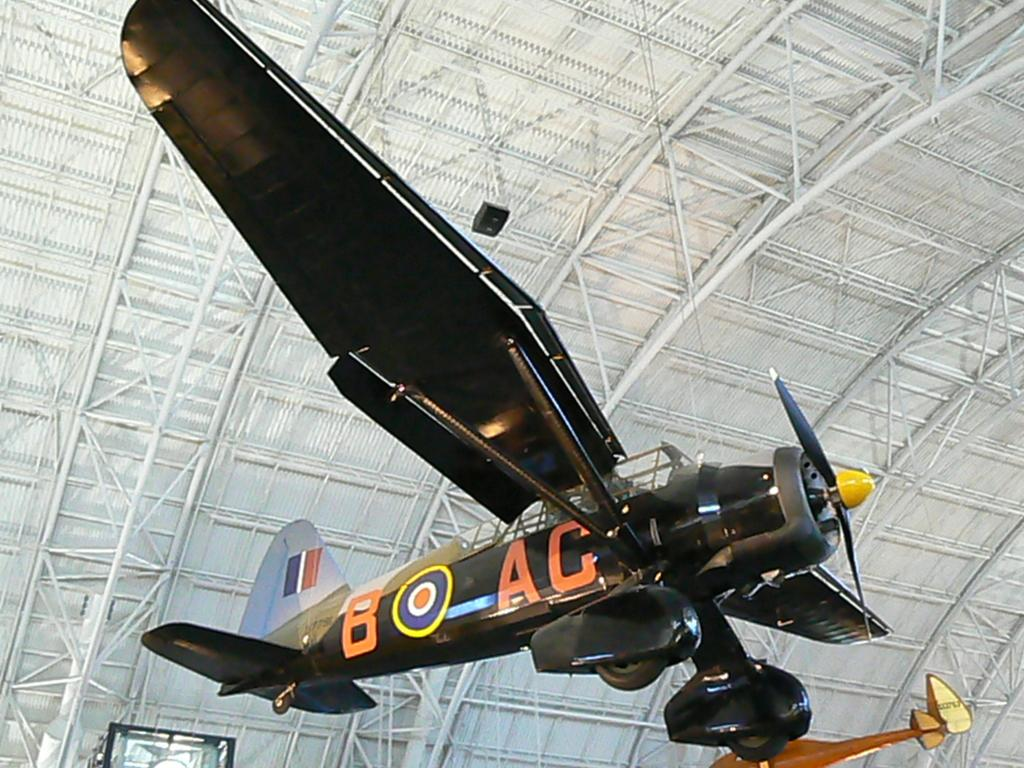Provide a one-sentence caption for the provided image. An aircraft labelled as B AC hanging from the roof of a hanger. 